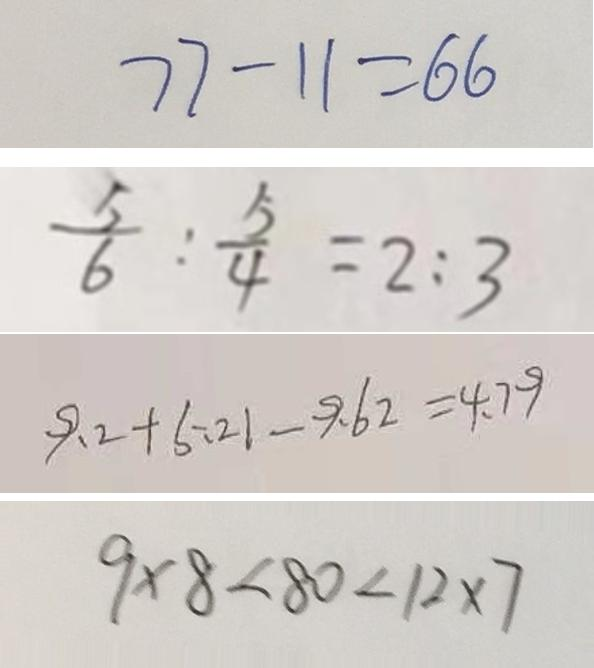<formula> <loc_0><loc_0><loc_500><loc_500>7 7 - 1 1 = 6 6 
 \frac { 5 } { 6 } : \frac { 5 } { 4 } = 2 : 3 
 9 . 2 + 5 . 2 1 - 9 . 6 2 = 4 . 7 9 
 9 \times 8 < 8 0 < 1 2 \times 7</formula> 